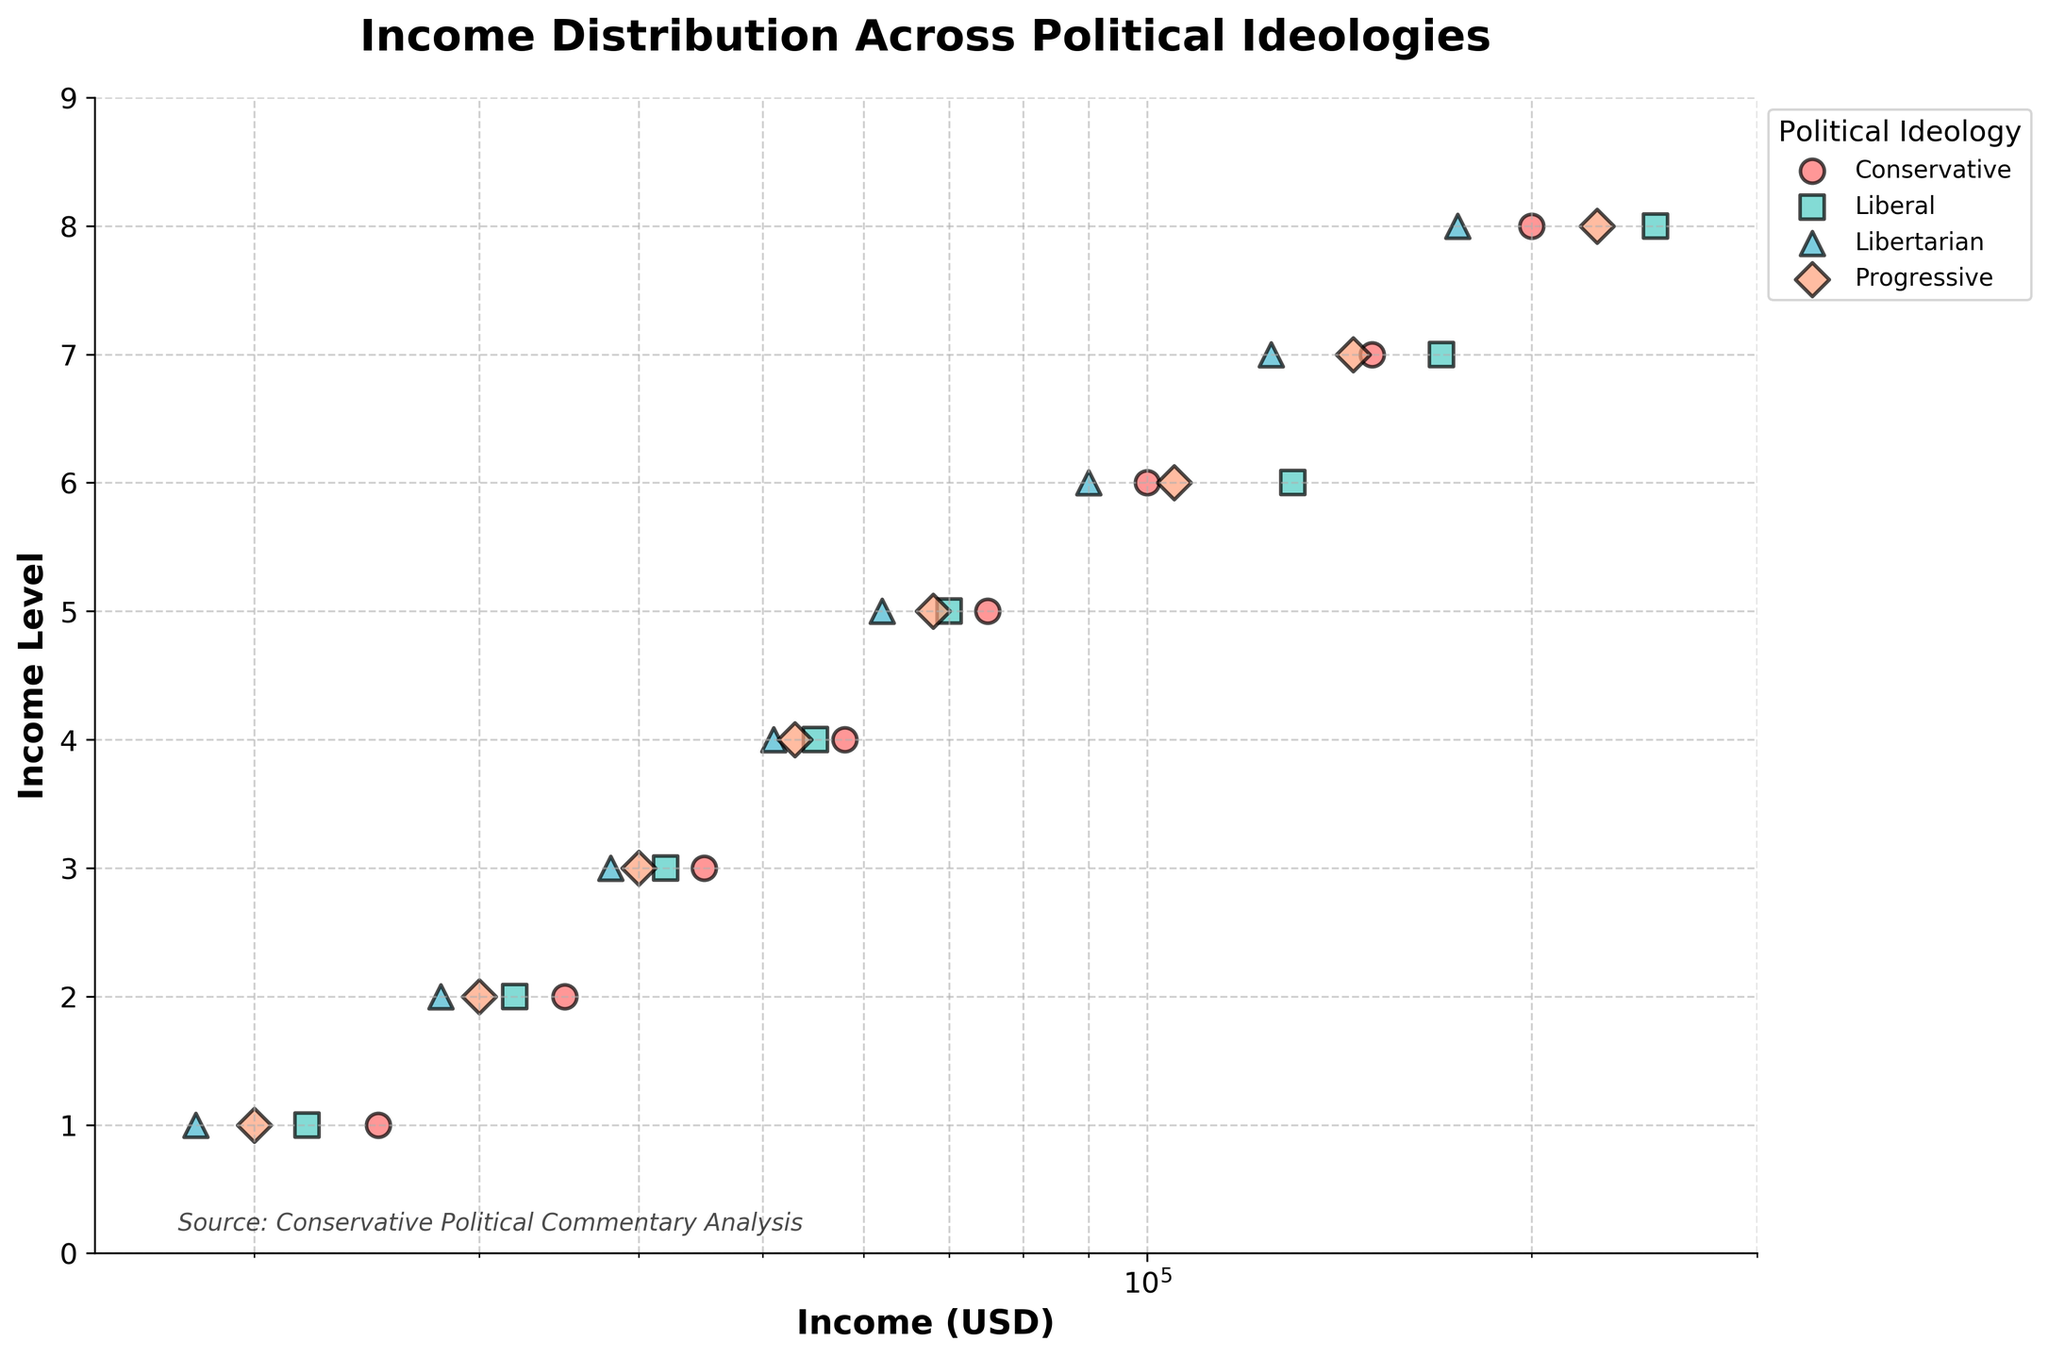What's the title of the figure? The title is written at the top of the plot and reads 'Income Distribution Across Political Ideologies'.
Answer: Income Distribution Across Political Ideologies What is the x-axis label? The x-axis label is shown below the horizontal axis and indicates what the scale represents. It reads 'Income (USD)'.
Answer: Income (USD) How many political ideologies are represented in the plot? The legend box to the right of the plot lists the political ideologies. There are four: Conservative, Liberal, Libertarian, and Progressive.
Answer: Four Which political ideology has the highest single income value? By looking at the position of the highest data point along the x-axis, we can see that the highest income value belongs to the Liberal ideology with an income of 250,000 USD.
Answer: Liberal What is the range of incomes for the Conservative ideology? The data points for Conservative on the x-axis range from the lowest to the highest. The lowest income is 25,000 USD and the highest is 200,000 USD.
Answer: 25,000 - 200,000 USD Which political ideology shows the greatest income disparity? To determine this, one should look at the spread of the points along the x-axis. The Progressive ideology has points that are furthest apart, ranging from 20,000 USD to 225,000 USD.
Answer: Progressive Compare the median income of Conservatives and Liberals To find the median, sort the incomes and identify the middle value. For Conservatives: 25,000, 35,000, 45,000, 58,000, 75,000, 100,000, 150,000, 200,000. Median is (58,000 + 75,000)/2 = 66,500 USD. For Liberals: 22,000, 32,000, 42,000, 55,000, 70,000, 130,000, 170,000, 250,000. Median is (55,000 + 70,000)/2 = 62,500 USD.
Answer: Conservatives: 66,500 USD, Liberals: 62,500 USD Which political ideology has the lowest income value? Looking at the left-most data points on the x-axis, the lowest income belongs to the Libertarian ideology at 18,000 USD.
Answer: Libertarian What income value can be observed in all four political ideologies? By finding common values along the x-axis for each ideology, 30,000 USD appears to be the closest common income value.
Answer: 30,000 USD 